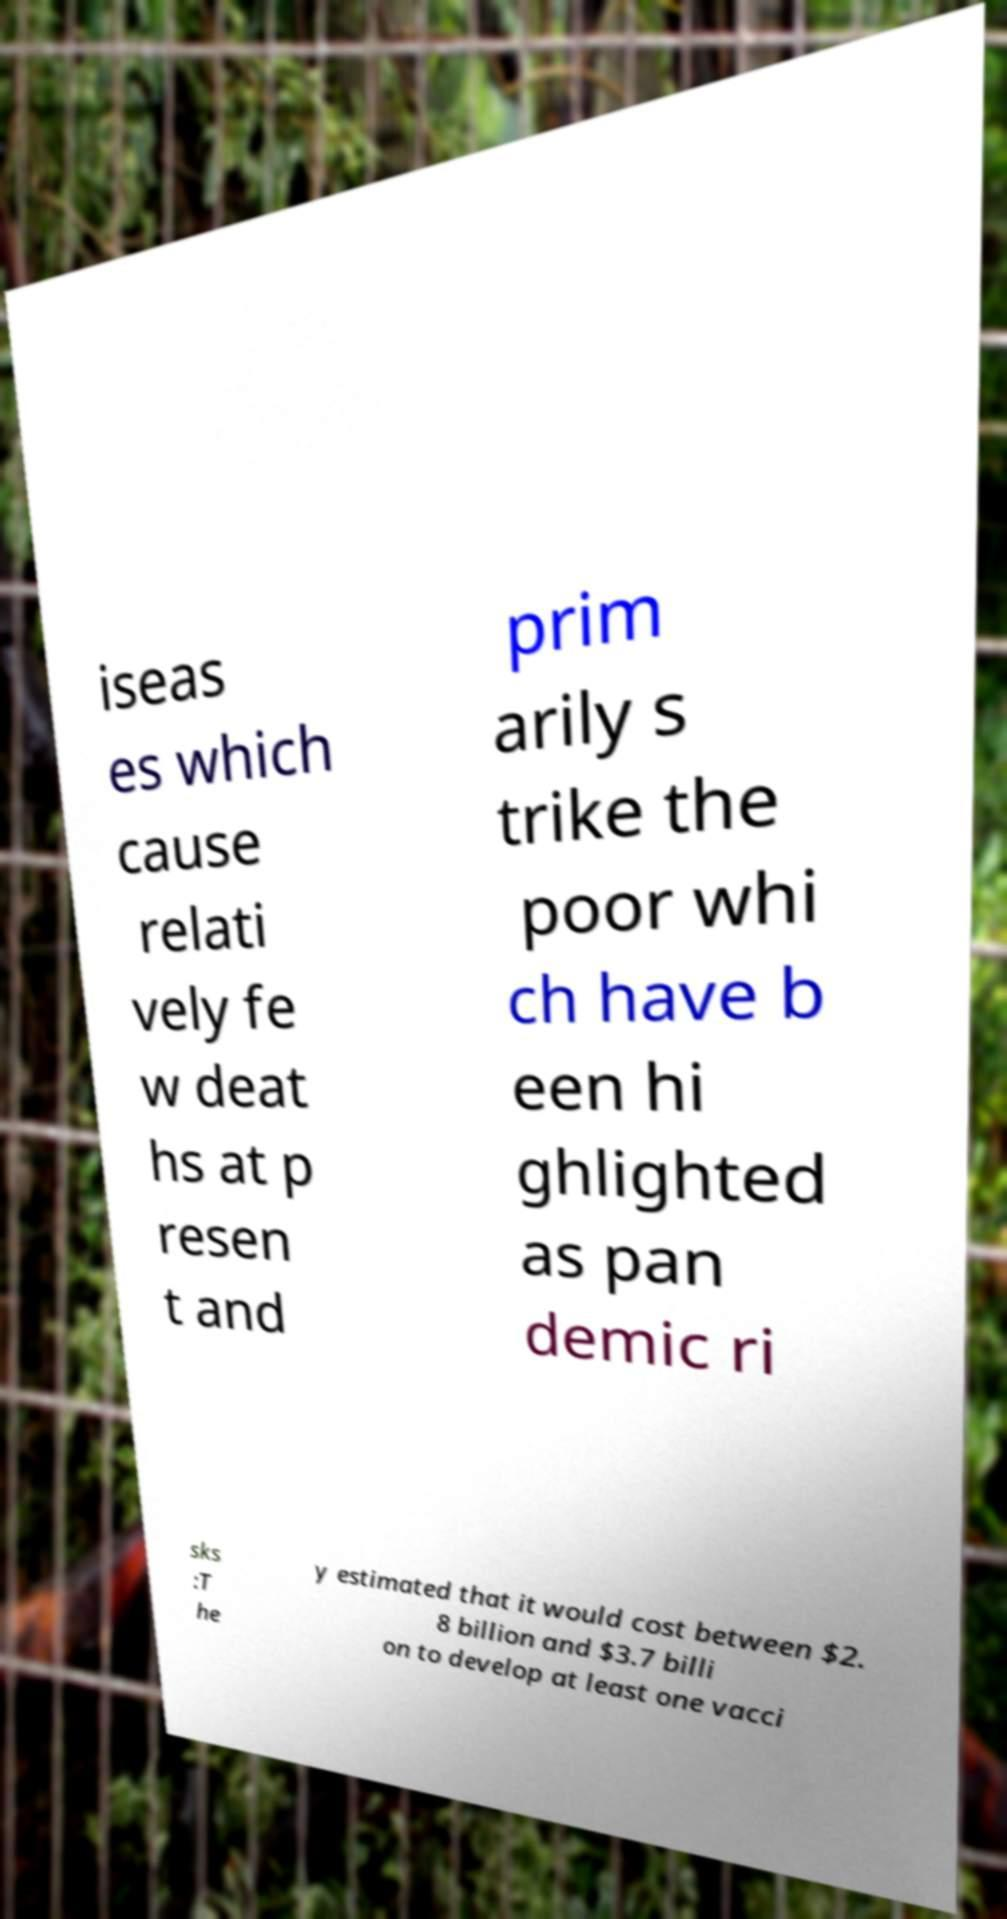For documentation purposes, I need the text within this image transcribed. Could you provide that? iseas es which cause relati vely fe w deat hs at p resen t and prim arily s trike the poor whi ch have b een hi ghlighted as pan demic ri sks :T he y estimated that it would cost between $2. 8 billion and $3.7 billi on to develop at least one vacci 